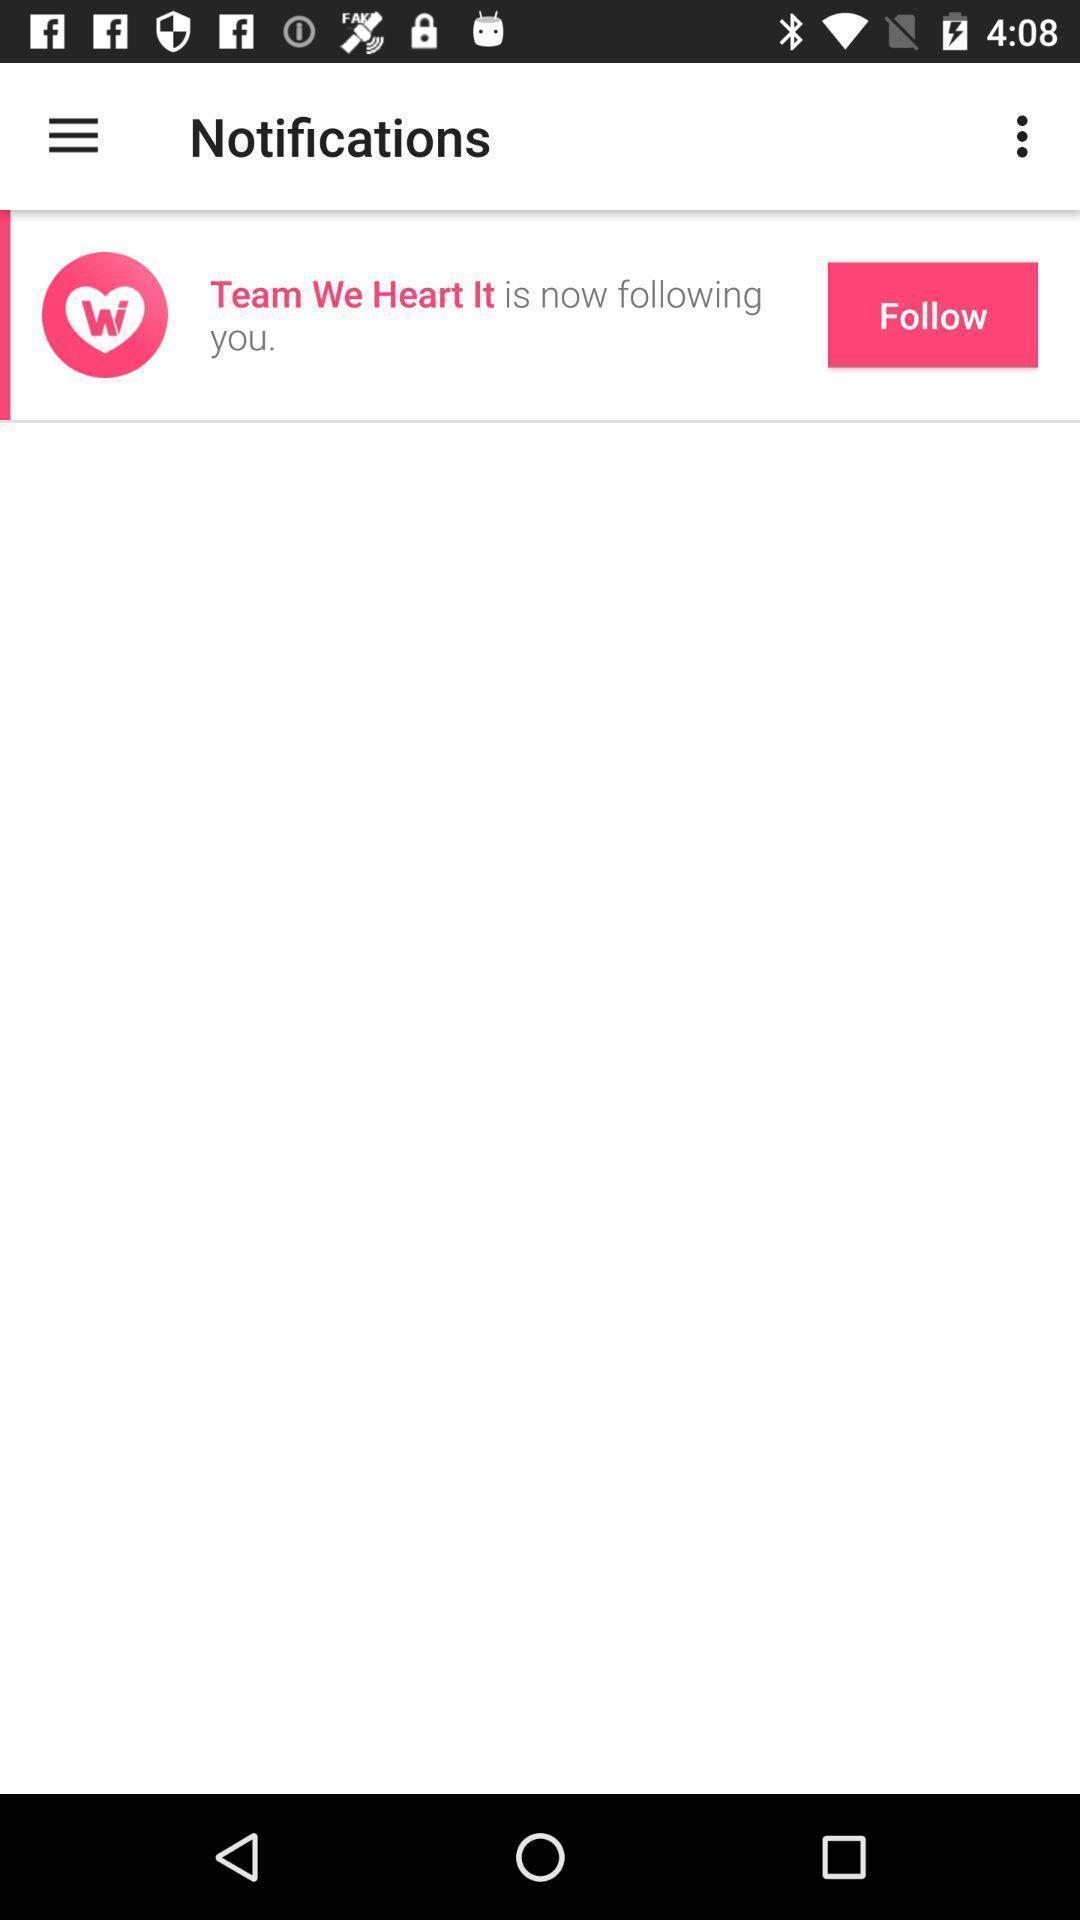Please provide a description for this image. Screen page displaying the options in social application. 